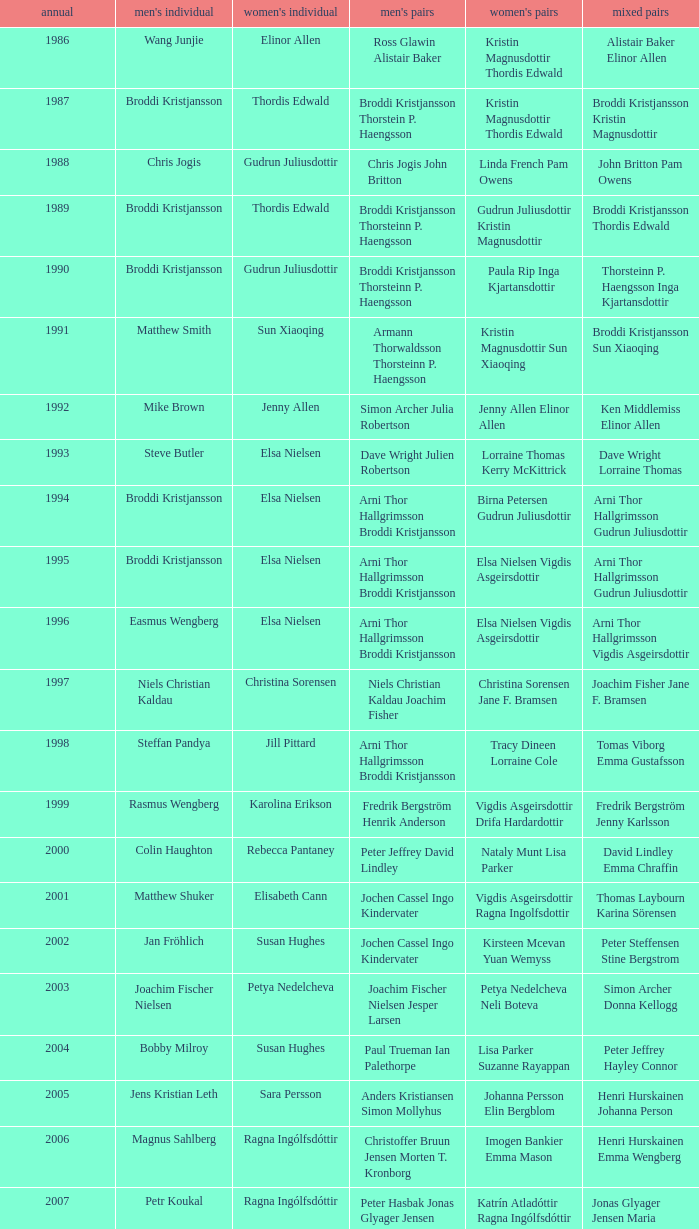In which women's doubles did Wang Junjie play men's singles? Kristin Magnusdottir Thordis Edwald. Can you give me this table as a dict? {'header': ['annual', "men's individual", "women's individual", "men's pairs", "women's pairs", 'mixed pairs'], 'rows': [['1986', 'Wang Junjie', 'Elinor Allen', 'Ross Glawin Alistair Baker', 'Kristin Magnusdottir Thordis Edwald', 'Alistair Baker Elinor Allen'], ['1987', 'Broddi Kristjansson', 'Thordis Edwald', 'Broddi Kristjansson Thorstein P. Haengsson', 'Kristin Magnusdottir Thordis Edwald', 'Broddi Kristjansson Kristin Magnusdottir'], ['1988', 'Chris Jogis', 'Gudrun Juliusdottir', 'Chris Jogis John Britton', 'Linda French Pam Owens', 'John Britton Pam Owens'], ['1989', 'Broddi Kristjansson', 'Thordis Edwald', 'Broddi Kristjansson Thorsteinn P. Haengsson', 'Gudrun Juliusdottir Kristin Magnusdottir', 'Broddi Kristjansson Thordis Edwald'], ['1990', 'Broddi Kristjansson', 'Gudrun Juliusdottir', 'Broddi Kristjansson Thorsteinn P. Haengsson', 'Paula Rip Inga Kjartansdottir', 'Thorsteinn P. Haengsson Inga Kjartansdottir'], ['1991', 'Matthew Smith', 'Sun Xiaoqing', 'Armann Thorwaldsson Thorsteinn P. Haengsson', 'Kristin Magnusdottir Sun Xiaoqing', 'Broddi Kristjansson Sun Xiaoqing'], ['1992', 'Mike Brown', 'Jenny Allen', 'Simon Archer Julia Robertson', 'Jenny Allen Elinor Allen', 'Ken Middlemiss Elinor Allen'], ['1993', 'Steve Butler', 'Elsa Nielsen', 'Dave Wright Julien Robertson', 'Lorraine Thomas Kerry McKittrick', 'Dave Wright Lorraine Thomas'], ['1994', 'Broddi Kristjansson', 'Elsa Nielsen', 'Arni Thor Hallgrimsson Broddi Kristjansson', 'Birna Petersen Gudrun Juliusdottir', 'Arni Thor Hallgrimsson Gudrun Juliusdottir'], ['1995', 'Broddi Kristjansson', 'Elsa Nielsen', 'Arni Thor Hallgrimsson Broddi Kristjansson', 'Elsa Nielsen Vigdis Asgeirsdottir', 'Arni Thor Hallgrimsson Gudrun Juliusdottir'], ['1996', 'Easmus Wengberg', 'Elsa Nielsen', 'Arni Thor Hallgrimsson Broddi Kristjansson', 'Elsa Nielsen Vigdis Asgeirsdottir', 'Arni Thor Hallgrimsson Vigdis Asgeirsdottir'], ['1997', 'Niels Christian Kaldau', 'Christina Sorensen', 'Niels Christian Kaldau Joachim Fisher', 'Christina Sorensen Jane F. Bramsen', 'Joachim Fisher Jane F. Bramsen'], ['1998', 'Steffan Pandya', 'Jill Pittard', 'Arni Thor Hallgrimsson Broddi Kristjansson', 'Tracy Dineen Lorraine Cole', 'Tomas Viborg Emma Gustafsson'], ['1999', 'Rasmus Wengberg', 'Karolina Erikson', 'Fredrik Bergström Henrik Anderson', 'Vigdis Asgeirsdottir Drifa Hardardottir', 'Fredrik Bergström Jenny Karlsson'], ['2000', 'Colin Haughton', 'Rebecca Pantaney', 'Peter Jeffrey David Lindley', 'Nataly Munt Lisa Parker', 'David Lindley Emma Chraffin'], ['2001', 'Matthew Shuker', 'Elisabeth Cann', 'Jochen Cassel Ingo Kindervater', 'Vigdis Asgeirsdottir Ragna Ingolfsdottir', 'Thomas Laybourn Karina Sörensen'], ['2002', 'Jan Fröhlich', 'Susan Hughes', 'Jochen Cassel Ingo Kindervater', 'Kirsteen Mcevan Yuan Wemyss', 'Peter Steffensen Stine Bergstrom'], ['2003', 'Joachim Fischer Nielsen', 'Petya Nedelcheva', 'Joachim Fischer Nielsen Jesper Larsen', 'Petya Nedelcheva Neli Boteva', 'Simon Archer Donna Kellogg'], ['2004', 'Bobby Milroy', 'Susan Hughes', 'Paul Trueman Ian Palethorpe', 'Lisa Parker Suzanne Rayappan', 'Peter Jeffrey Hayley Connor'], ['2005', 'Jens Kristian Leth', 'Sara Persson', 'Anders Kristiansen Simon Mollyhus', 'Johanna Persson Elin Bergblom', 'Henri Hurskainen Johanna Person'], ['2006', 'Magnus Sahlberg', 'Ragna Ingólfsdóttir', 'Christoffer Bruun Jensen Morten T. Kronborg', 'Imogen Bankier Emma Mason', 'Henri Hurskainen Emma Wengberg'], ['2007', 'Petr Koukal', 'Ragna Ingólfsdóttir', 'Peter Hasbak Jonas Glyager Jensen', 'Katrín Atladóttir Ragna Ingólfsdóttir', 'Jonas Glyager Jensen Maria Kaaberböl Thorberg'], ['2008', 'No competition', 'No competition', 'No competition', 'No competition', 'No competition'], ['2009', 'Christian Lind Thomsen', 'Ragna Ingólfsdóttir', 'Anders Skaarup Rasmussen René Lindskow', 'Ragna Ingólfsdóttir Snjólaug Jóhannsdóttir', 'Theis Christiansen Joan Christiansen'], ['2010', 'Kim Bruun', 'Ragna Ingólfsdóttir', 'Emil Holst Mikkel Mikkelsen', 'Katrín Atladóttir Ragna Ingólfsdóttir', 'Frederik Colberg Mette Poulsen'], ['2011', 'Mathias Borg', 'Ragna Ingólfsdóttir', 'Thomas Dew-Hattens Mathias Kany', 'Tinna Helgadóttir Snjólaug Jóhannsdóttir', 'Thomas Dew-Hattens Louise Hansen'], ['2012', 'Chou Tien-chen', 'Chiang Mei-hui', 'Joe Morgan Nic Strange', 'Lee So-hee Shin Seung-chan', 'Chou Tien-chen Chiang Mei-hui']]} 